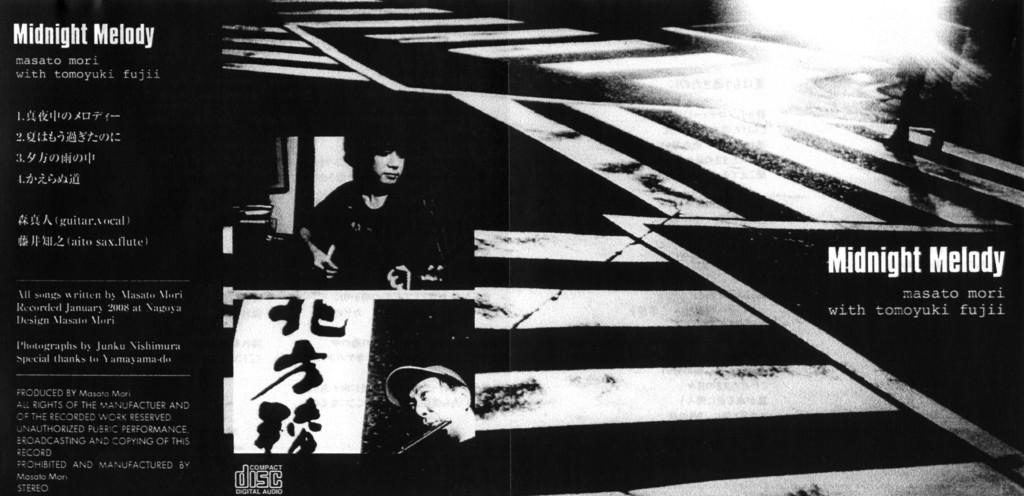What time is the melody?
Your answer should be compact. Midnight. What is the name of the album?
Keep it short and to the point. Midnight melody. 